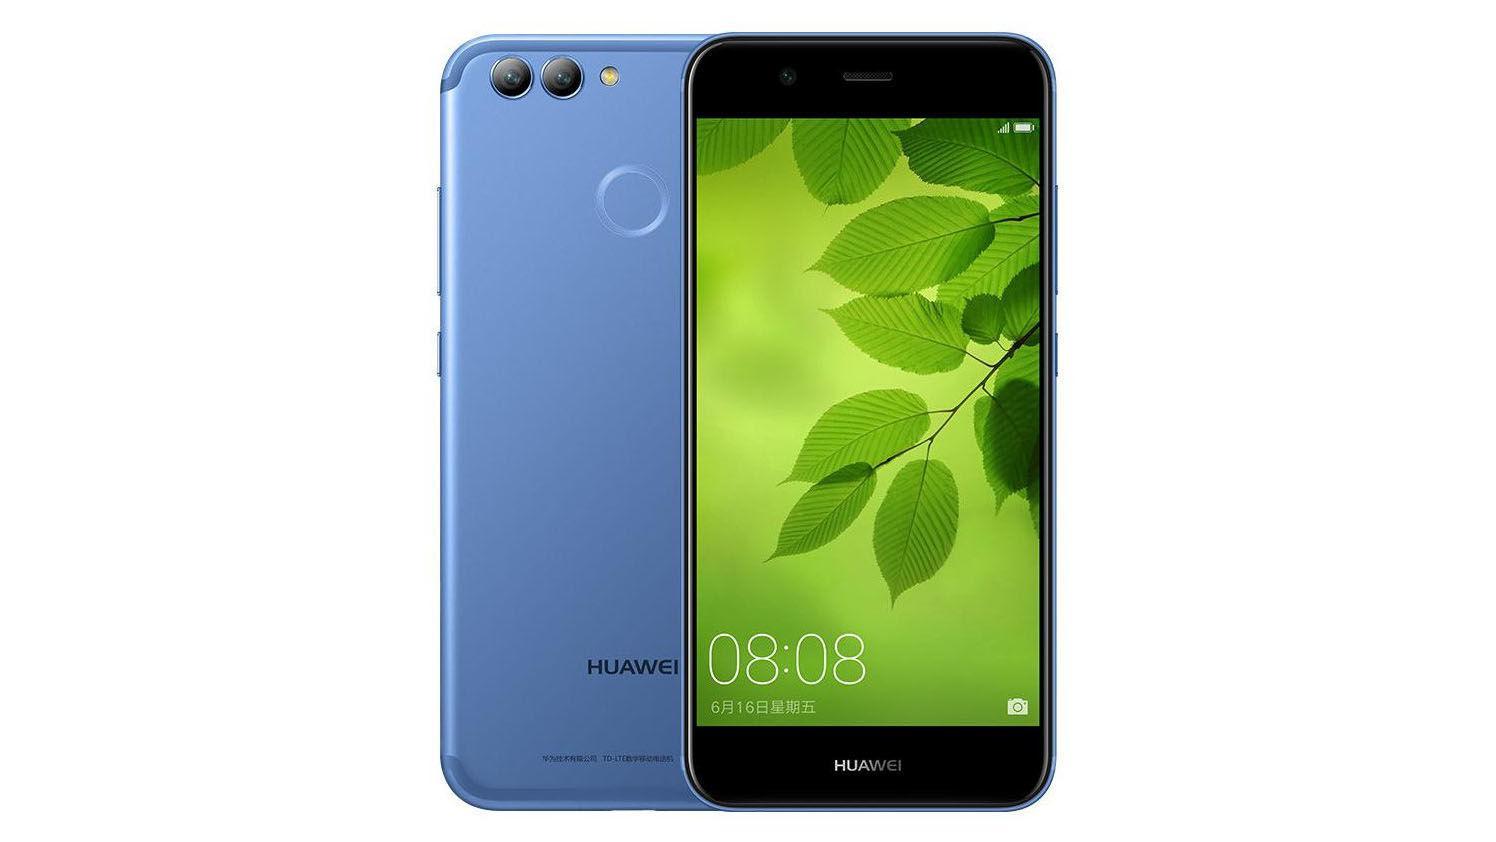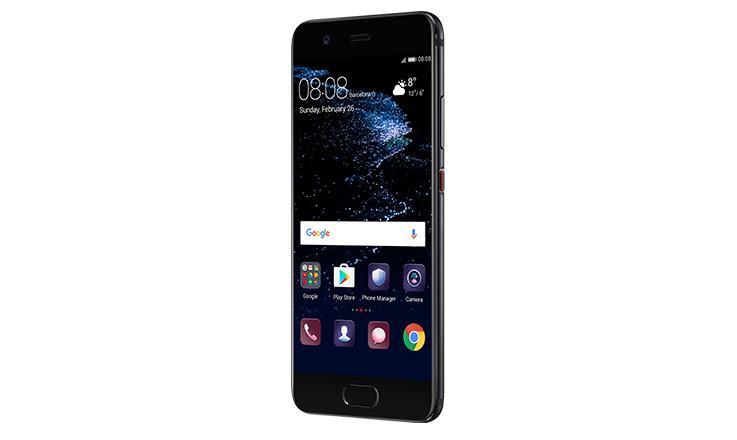The first image is the image on the left, the second image is the image on the right. For the images displayed, is the sentence "One image shows the front and the back of a smartphone and the other shows only the front of a smartphone." factually correct? Answer yes or no. Yes. The first image is the image on the left, the second image is the image on the right. Analyze the images presented: Is the assertion "The left image shows a phone screen side-up that is on the right and overlapping a back-turned phone, and the right image shows only a phone's screen side." valid? Answer yes or no. Yes. 